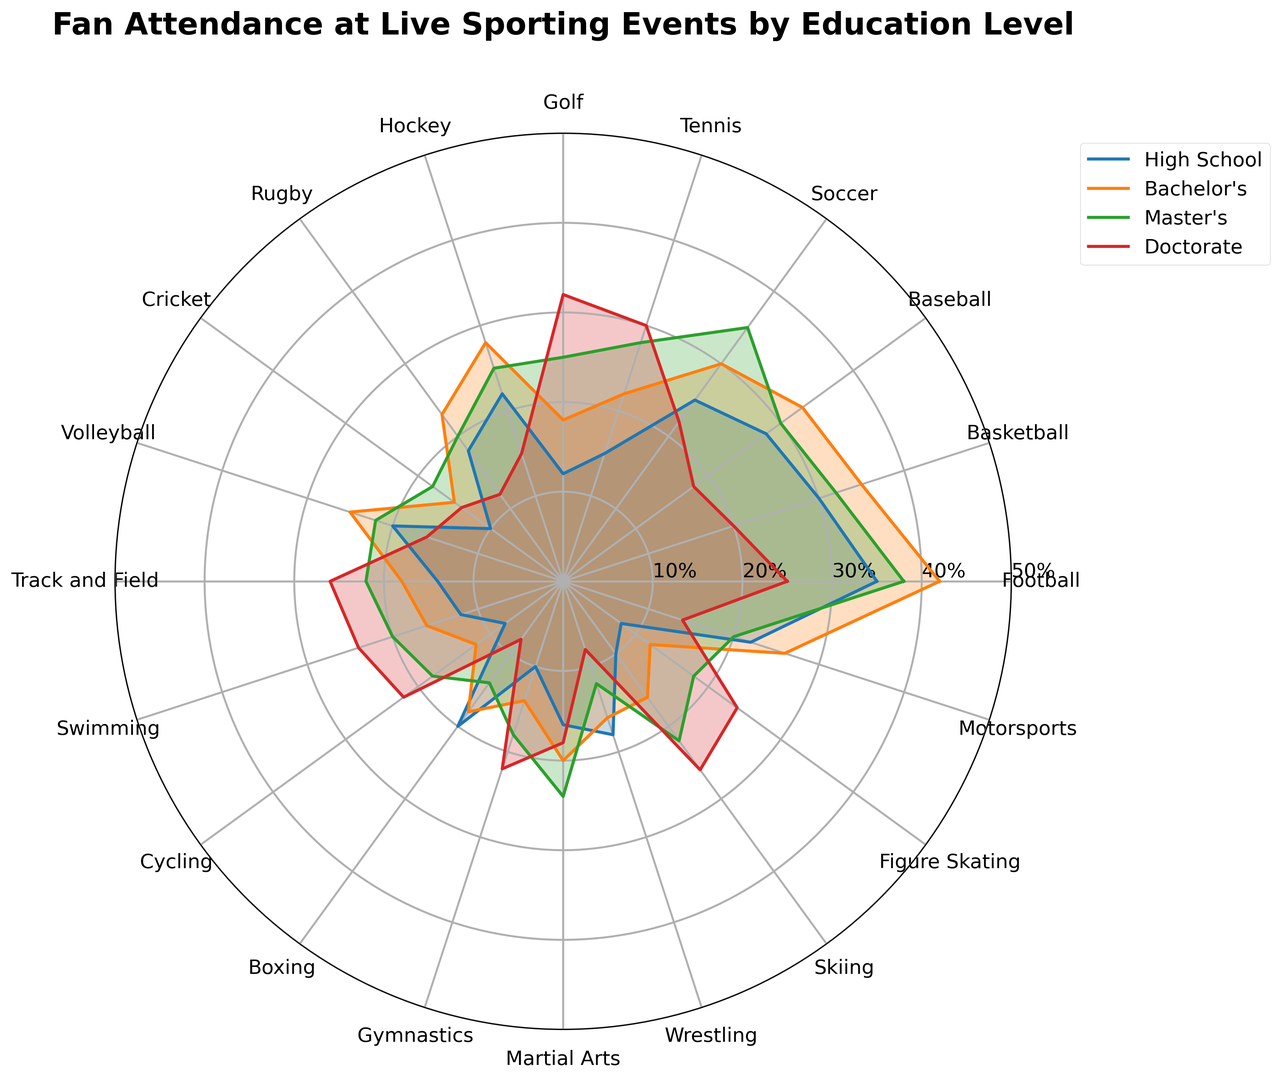What's the sport with the highest percentage of fans with a Doctorate degree? Look at the radial plot lines representing Doctorate degrees (likely distinguished by their color). Compare the lengths across all sports. The longest line indicates the highest percentage of fans with a Doctorate degree. Golf has the highest percentage.
Answer: Golf Which education level has the closest attendance percentage between Football and Basketball? Check the radial plot lines for both Football and Basketball across all education levels. Compare the values visually or by distances on the chart. Both Bachelor's and Master's levels have 42% and 38% for Football and 35% and 32% for Basketball, respectively, the Master's level is closer.
Answer: Master's What is the difference in attendance percentage between High School and Doctorate degrees for Tennis? Locate the radial plot lines specific to Tennis and note the percentage values for High School and Doctorate. Both values are visually presented around 15% for High School and 30% for Doctorate. Subtract 15% from 30%.
Answer: 15% Which sport has the smallest disparity in attendance percentages across all education levels? Inspect the length of lines for each sport across all education levels. The sport with the most similar lengths for all levels demonstrates the smallest disparity. Rugby appears to have the smallest disparity with percentages around 20-23%.
Answer: Rugby For which sport do Bachelor's degree holders show a significantly higher attendance percentage compared to high schoolers? Examine the radial plot lines for Bachelor's and High School levels. Identify which sport shows a noticeable jump in line length from High School to Bachelor's. Master's degrees plot has notable growth for sports like Football and Basketball. Football, for instance, jumps from 35% to 42%.
Answer: Football How much higher is the percentage of Master's degree fans of Soccer compared to Bachelor's degree fans of Volleyball? Find the values for Soccer using Master's (35%) and Volleyball using Bachelor's (25%). Compare them by subtracting Volleyball's Bachelor's from Soccer's Master's: 35% - 25%.
Answer: 10% Which education level exhibits the widest range of attendance percentages across all sports? Analyze the spread of plot line lengths for each education level across sports. Identify the one with the largest maximum and minimum values difference. Doctorate degree fan attends ranges between low 8% in few sports like Boxing to high 32% for Golf. Master’s has a significant range as well.
Answer: Doctorate What's the sum of attendance percentages for Rugby and Gymnastics for Master's degree holders? Locate and sum the radial plot values for Master's degree for Rugby (20%) and Gymnastics (18%).
Answer: 38% Which has higher attendance percentage: Bachelor's degree fans of Hockey or Master's degree fans of Track and Field? Compare the relevant radial plot values for Hockey (Bachelor's) at 28% and Track and Field (Master's) at 22%.
Answer: Hockey In visual terms, which color might be representing the Bachelor's degree level and how can you infer this? Refer to the corresponding hues in the radial plot lines. Compare the color coding in the legend with the length of Bachelor's degree values which look significant in sports like Football at 42%.
Answer: Color representing Bachelor's degree likely 